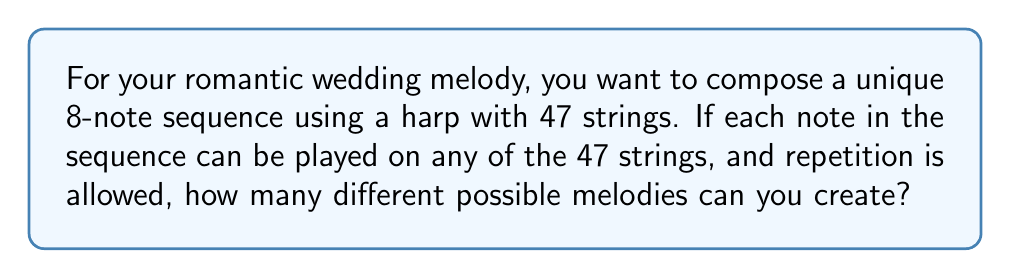Could you help me with this problem? Let's approach this step-by-step:

1) We are selecting 8 notes in sequence.
2) For each note, we have 47 choices (strings) to choose from.
3) We can repeat strings (notes) in our sequence.
4) The order of selection matters (different orders create different melodies).

This scenario is a perfect example of the multiplication principle with replacement.

For the first note, we have 47 choices.
For the second note, we again have 47 choices.
This continues for all 8 notes.

Therefore, the total number of possible melodies is:

$$ 47 \times 47 \times 47 \times 47 \times 47 \times 47 \times 47 \times 47 $$

This can be written more concisely as:

$$ 47^8 $$

Calculating this:

$$ 47^8 = 1,880,558,531,121 $$

This means there are 1,880,558,531,121 different possible 8-note melodies you can create on your 47-string harp for your romantic wedding melody.
Answer: $47^8 = 1,880,558,531,121$ 